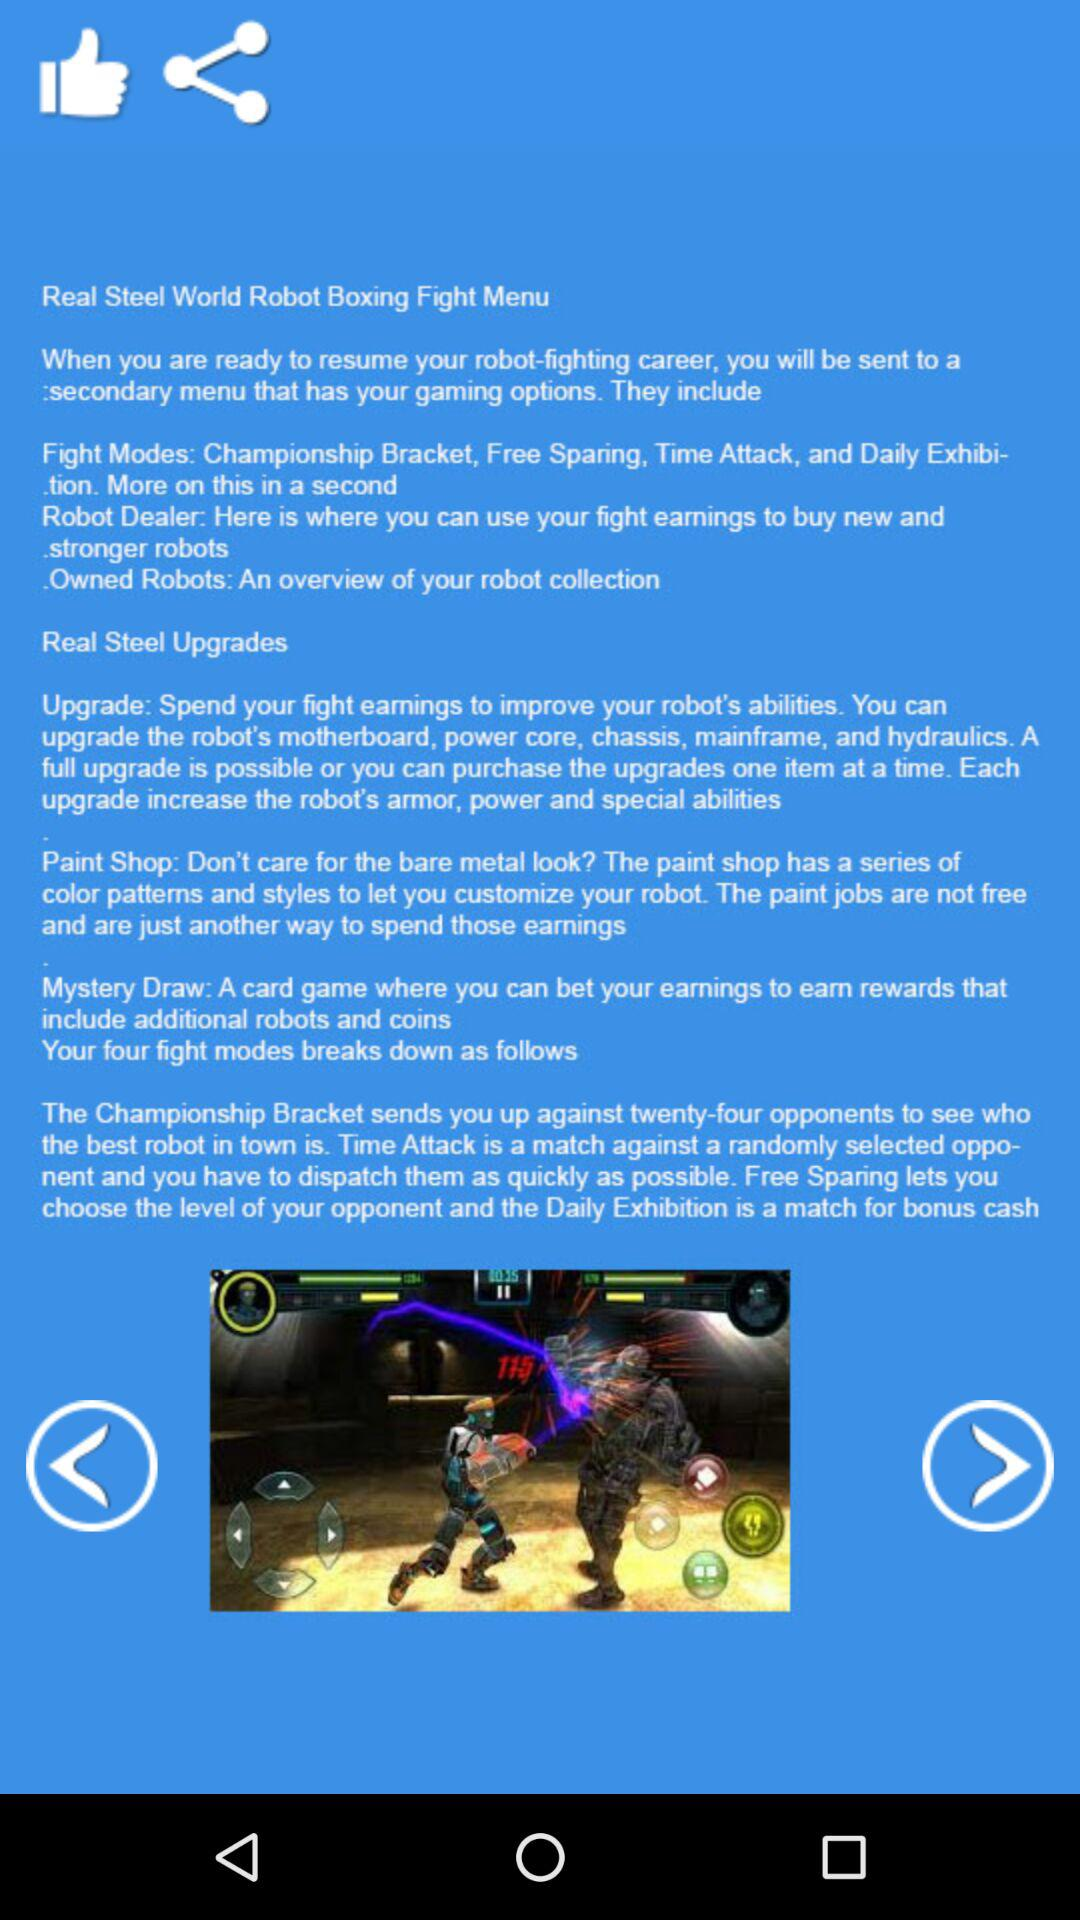How many fight modes are there in the game?
Answer the question using a single word or phrase. 4 